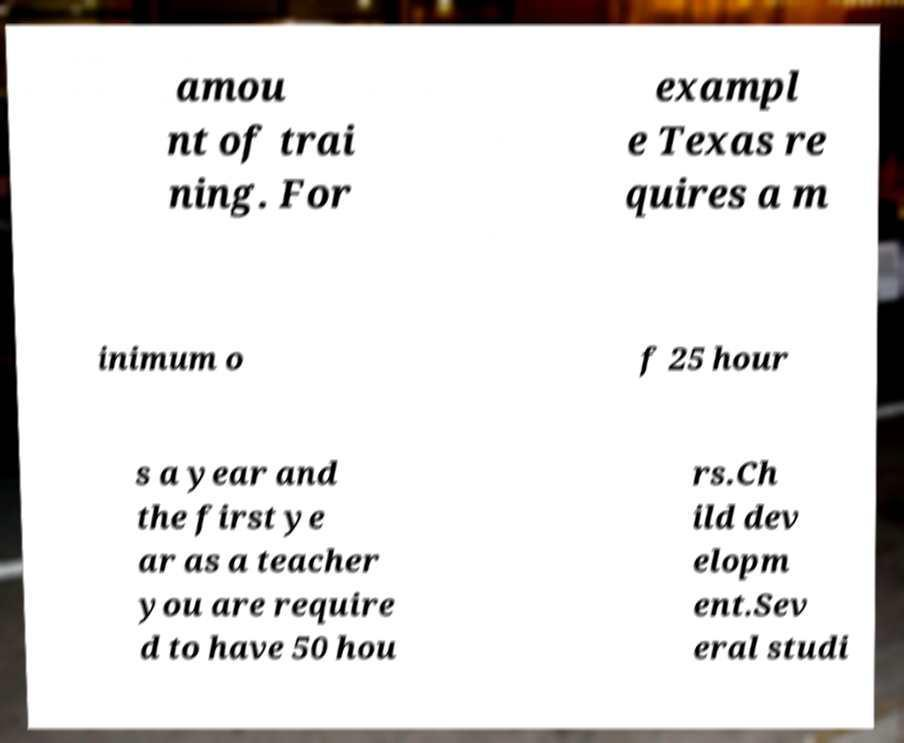What messages or text are displayed in this image? I need them in a readable, typed format. amou nt of trai ning. For exampl e Texas re quires a m inimum o f 25 hour s a year and the first ye ar as a teacher you are require d to have 50 hou rs.Ch ild dev elopm ent.Sev eral studi 